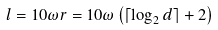Convert formula to latex. <formula><loc_0><loc_0><loc_500><loc_500>l = 1 0 \omega r = 1 0 \omega \left ( \lceil \log _ { 2 } d \rceil + 2 \right )</formula> 